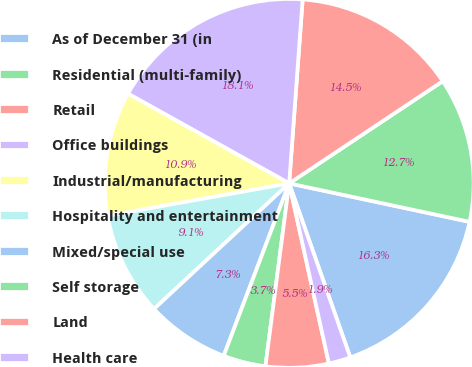Convert chart to OTSL. <chart><loc_0><loc_0><loc_500><loc_500><pie_chart><fcel>As of December 31 (in<fcel>Residential (multi-family)<fcel>Retail<fcel>Office buildings<fcel>Industrial/manufacturing<fcel>Hospitality and entertainment<fcel>Mixed/special use<fcel>Self storage<fcel>Land<fcel>Health care<nl><fcel>16.28%<fcel>12.69%<fcel>14.49%<fcel>18.08%<fcel>10.9%<fcel>9.1%<fcel>7.31%<fcel>3.72%<fcel>5.51%<fcel>1.92%<nl></chart> 